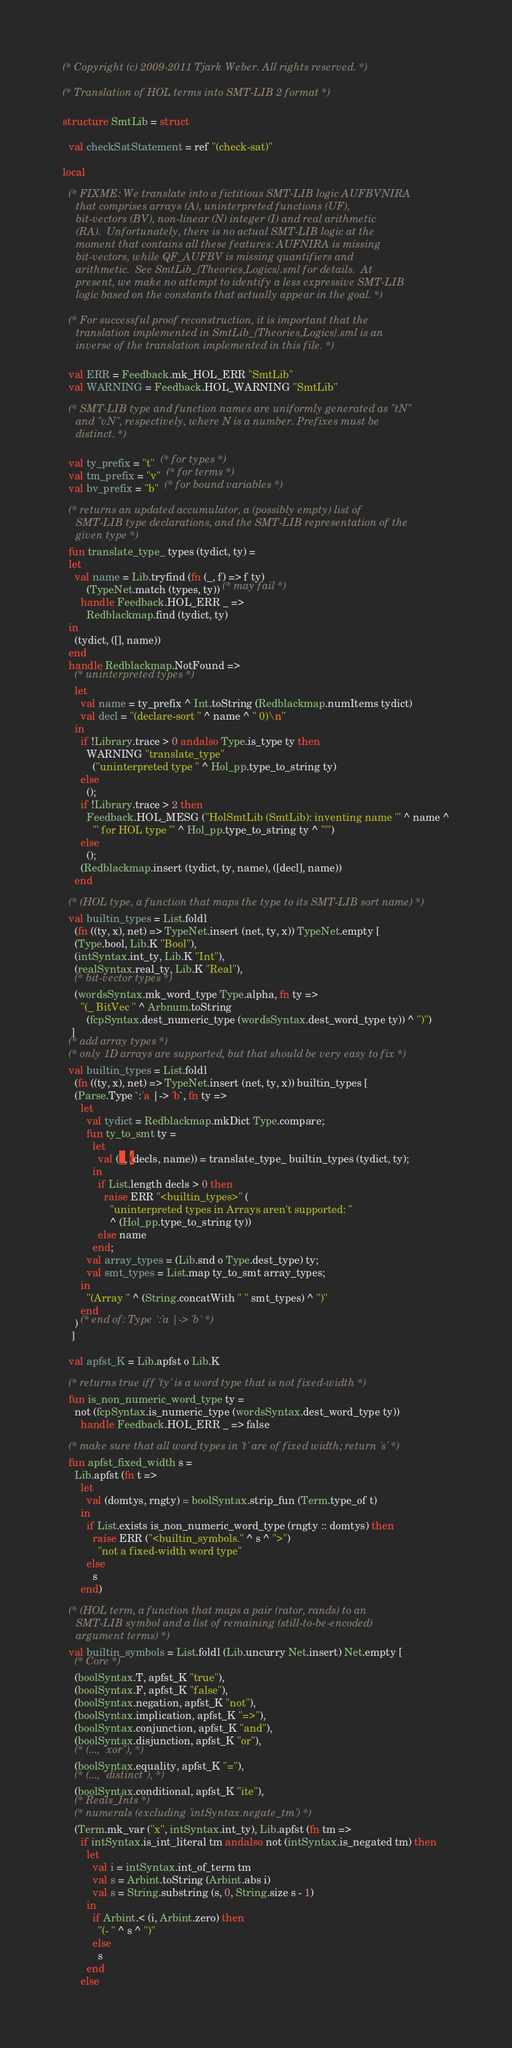<code> <loc_0><loc_0><loc_500><loc_500><_SML_>(* Copyright (c) 2009-2011 Tjark Weber. All rights reserved. *)

(* Translation of HOL terms into SMT-LIB 2 format *)

structure SmtLib = struct

  val checkSatStatement = ref "(check-sat)"

local

  (* FIXME: We translate into a fictitious SMT-LIB logic AUFBVNIRA
     that comprises arrays (A), uninterpreted functions (UF),
     bit-vectors (BV), non-linear (N) integer (I) and real arithmetic
     (RA).  Unfortunately, there is no actual SMT-LIB logic at the
     moment that contains all these features: AUFNIRA is missing
     bit-vectors, while QF_AUFBV is missing quantifiers and
     arithmetic.  See SmtLib_{Theories,Logics}.sml for details.  At
     present, we make no attempt to identify a less expressive SMT-LIB
     logic based on the constants that actually appear in the goal. *)

  (* For successful proof reconstruction, it is important that the
     translation implemented in SmtLib_{Theories,Logics}.sml is an
     inverse of the translation implemented in this file. *)

  val ERR = Feedback.mk_HOL_ERR "SmtLib"
  val WARNING = Feedback.HOL_WARNING "SmtLib"

  (* SMT-LIB type and function names are uniformly generated as "tN"
     and "vN", respectively, where N is a number. Prefixes must be
     distinct. *)

  val ty_prefix = "t"  (* for types *)
  val tm_prefix = "v"  (* for terms *)
  val bv_prefix = "b"  (* for bound variables *)

  (* returns an updated accumulator, a (possibly empty) list of
     SMT-LIB type declarations, and the SMT-LIB representation of the
     given type *)
  fun translate_type_ types (tydict, ty) =
  let
    val name = Lib.tryfind (fn (_, f) => f ty)
        (TypeNet.match (types, ty)) (* may fail *)
      handle Feedback.HOL_ERR _ =>
        Redblackmap.find (tydict, ty)
  in
    (tydict, ([], name))
  end
  handle Redblackmap.NotFound =>
    (* uninterpreted types *)
    let
      val name = ty_prefix ^ Int.toString (Redblackmap.numItems tydict)
      val decl = "(declare-sort " ^ name ^ " 0)\n"
    in
      if !Library.trace > 0 andalso Type.is_type ty then
        WARNING "translate_type"
          ("uninterpreted type " ^ Hol_pp.type_to_string ty)
      else
        ();
      if !Library.trace > 2 then
        Feedback.HOL_MESG ("HolSmtLib (SmtLib): inventing name '" ^ name ^
          "' for HOL type '" ^ Hol_pp.type_to_string ty ^ "'")
      else
        ();
      (Redblackmap.insert (tydict, ty, name), ([decl], name))
    end

  (* (HOL type, a function that maps the type to its SMT-LIB sort name) *)
  val builtin_types = List.foldl
    (fn ((ty, x), net) => TypeNet.insert (net, ty, x)) TypeNet.empty [
    (Type.bool, Lib.K "Bool"),
    (intSyntax.int_ty, Lib.K "Int"),
    (realSyntax.real_ty, Lib.K "Real"),
    (* bit-vector types *)
    (wordsSyntax.mk_word_type Type.alpha, fn ty =>
      "(_ BitVec " ^ Arbnum.toString
        (fcpSyntax.dest_numeric_type (wordsSyntax.dest_word_type ty)) ^ ")")
   ]
  (* add array types *)
  (* only 1D arrays are supported, but that should be very easy to fix *)
  val builtin_types = List.foldl
    (fn ((ty, x), net) => TypeNet.insert (net, ty, x)) builtin_types [
    (Parse.Type `:'a |-> 'b`, fn ty =>
      let
        val tydict = Redblackmap.mkDict Type.compare;
        fun ty_to_smt ty =
          let
            val (_, (decls, name)) = translate_type_ builtin_types (tydict, ty);
          in
            if List.length decls > 0 then
              raise ERR "<builtin_types>" (
                "uninterpreted types in Arrays aren't supported: "
                ^ (Hol_pp.type_to_string ty))
            else name
          end;
        val array_types = (Lib.snd o Type.dest_type) ty;
        val smt_types = List.map ty_to_smt array_types;
      in
        "(Array " ^ (String.concatWith " " smt_types) ^ ")"
      end
    ) (* end of: Type `:'a |-> 'b` *)
   ]

  val apfst_K = Lib.apfst o Lib.K

  (* returns true iff 'ty' is a word type that is not fixed-width *)
  fun is_non_numeric_word_type ty =
    not (fcpSyntax.is_numeric_type (wordsSyntax.dest_word_type ty))
      handle Feedback.HOL_ERR _ => false

  (* make sure that all word types in 't' are of fixed width; return 's' *)
  fun apfst_fixed_width s =
    Lib.apfst (fn t =>
      let
        val (domtys, rngty) = boolSyntax.strip_fun (Term.type_of t)
      in
        if List.exists is_non_numeric_word_type (rngty :: domtys) then
          raise ERR ("<builtin_symbols." ^ s ^ ">")
            "not a fixed-width word type"
        else
          s
      end)

  (* (HOL term, a function that maps a pair (rator, rands) to an
     SMT-LIB symbol and a list of remaining (still-to-be-encoded)
     argument terms) *)
  val builtin_symbols = List.foldl (Lib.uncurry Net.insert) Net.empty [
    (* Core *)
    (boolSyntax.T, apfst_K "true"),
    (boolSyntax.F, apfst_K "false"),
    (boolSyntax.negation, apfst_K "not"),
    (boolSyntax.implication, apfst_K "=>"),
    (boolSyntax.conjunction, apfst_K "and"),
    (boolSyntax.disjunction, apfst_K "or"),
    (* (..., "xor"), *)
    (boolSyntax.equality, apfst_K "="),
    (* (..., "distinct"), *)
    (boolSyntax.conditional, apfst_K "ite"),
    (* Reals_Ints *)
    (* numerals (excluding 'intSyntax.negate_tm') *)
    (Term.mk_var ("x", intSyntax.int_ty), Lib.apfst (fn tm =>
      if intSyntax.is_int_literal tm andalso not (intSyntax.is_negated tm) then
        let
          val i = intSyntax.int_of_term tm
          val s = Arbint.toString (Arbint.abs i)
          val s = String.substring (s, 0, String.size s - 1)
        in
          if Arbint.< (i, Arbint.zero) then
            "(- " ^ s ^ ")"
          else
            s
        end
      else</code> 